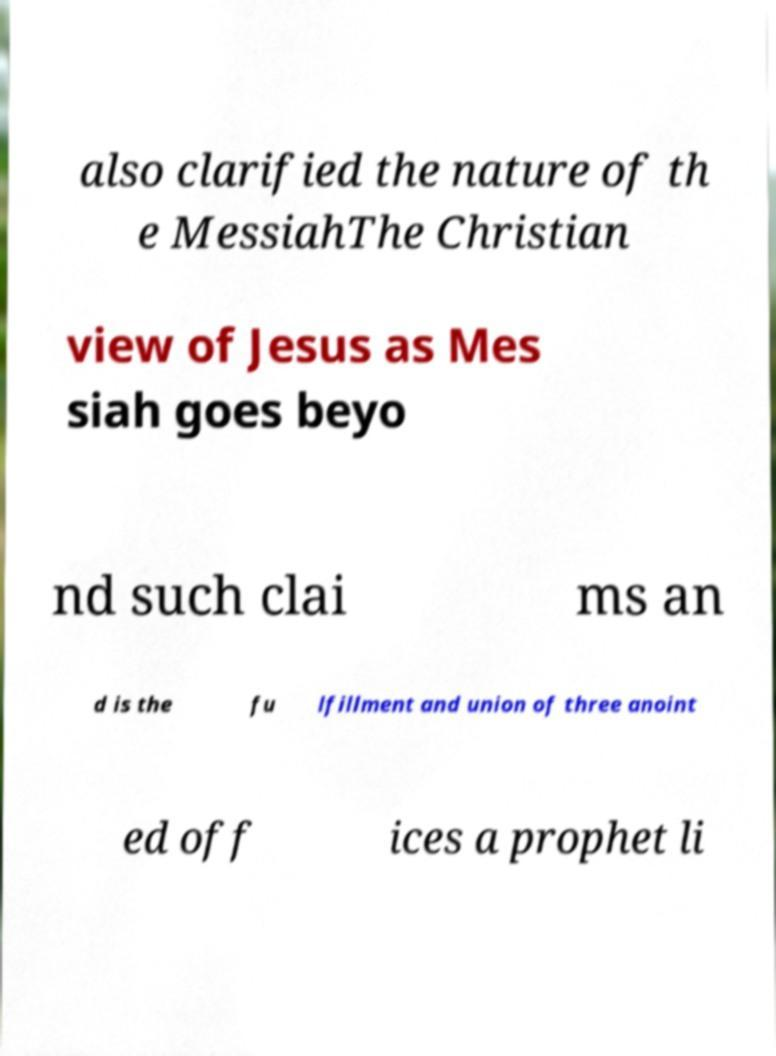Can you read and provide the text displayed in the image?This photo seems to have some interesting text. Can you extract and type it out for me? also clarified the nature of th e MessiahThe Christian view of Jesus as Mes siah goes beyo nd such clai ms an d is the fu lfillment and union of three anoint ed off ices a prophet li 